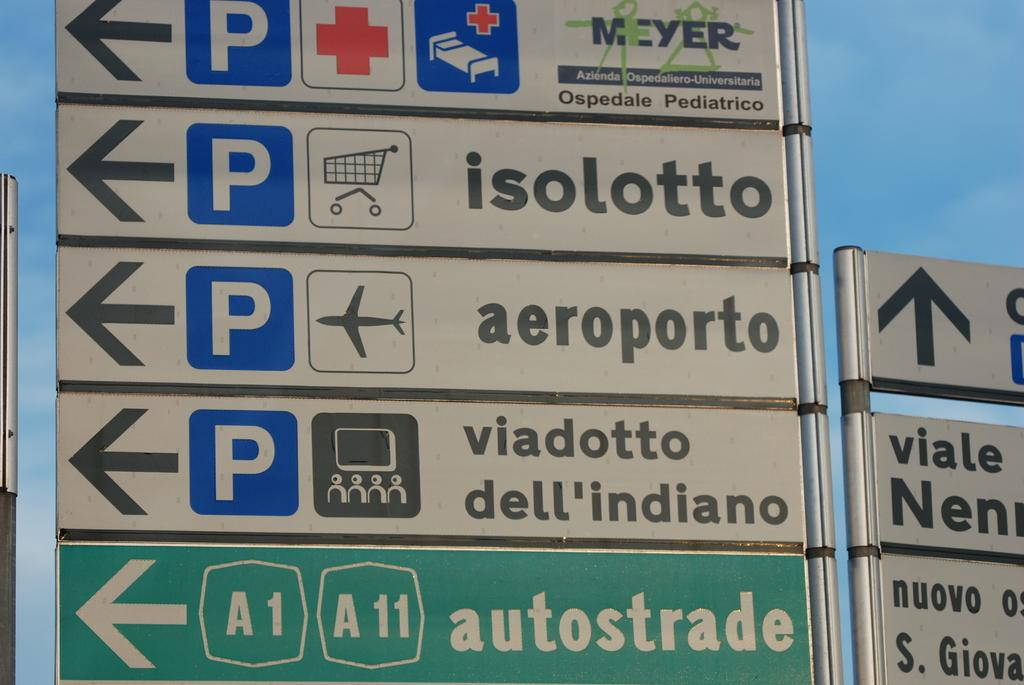<image>
Describe the image concisely. A sign points to different locations, including an airport and a supermarket. 